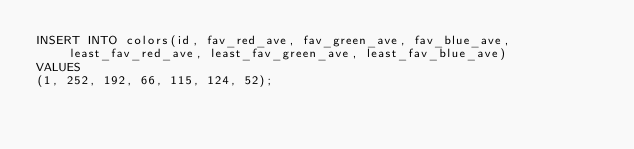Convert code to text. <code><loc_0><loc_0><loc_500><loc_500><_SQL_>INSERT INTO colors(id, fav_red_ave, fav_green_ave, fav_blue_ave, least_fav_red_ave, least_fav_green_ave, least_fav_blue_ave) 
VALUES
(1, 252, 192, 66, 115, 124, 52);</code> 